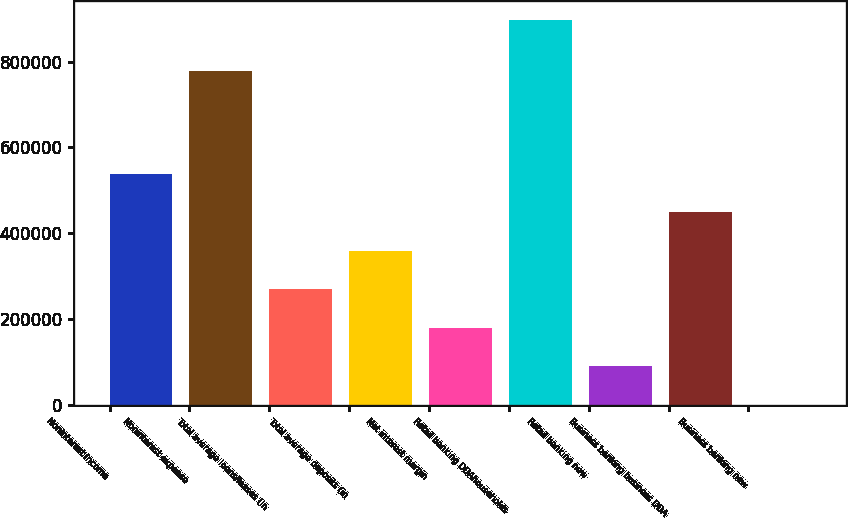<chart> <loc_0><loc_0><loc_500><loc_500><bar_chart><fcel>Noninterest income<fcel>Noninterest expense<fcel>Total average loans/leases (in<fcel>Total average deposits (in<fcel>Net interest margin<fcel>Retail banking DDAhouseholds<fcel>Retail banking new<fcel>Business banking business DDA<fcel>Business banking new<nl><fcel>537848<fcel>779010<fcel>268925<fcel>358566<fcel>179284<fcel>896412<fcel>89643<fcel>448207<fcel>2.03<nl></chart> 